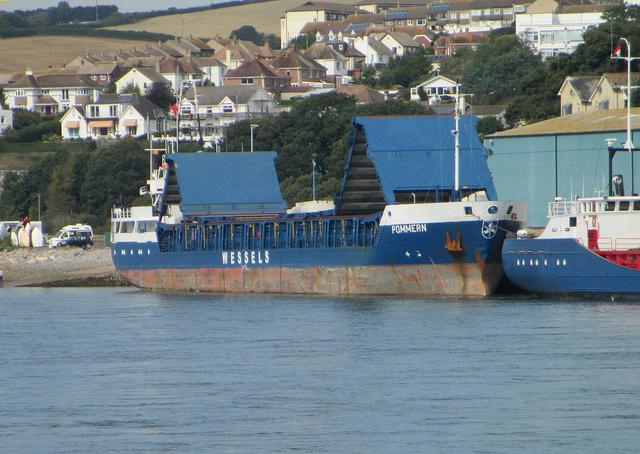Is there a body of water in the scene?
Answer briefly. Yes. Are these vessels for tourism and recreation purposes?
Short answer required. No. Is there a town in the background?
Concise answer only. Yes. 